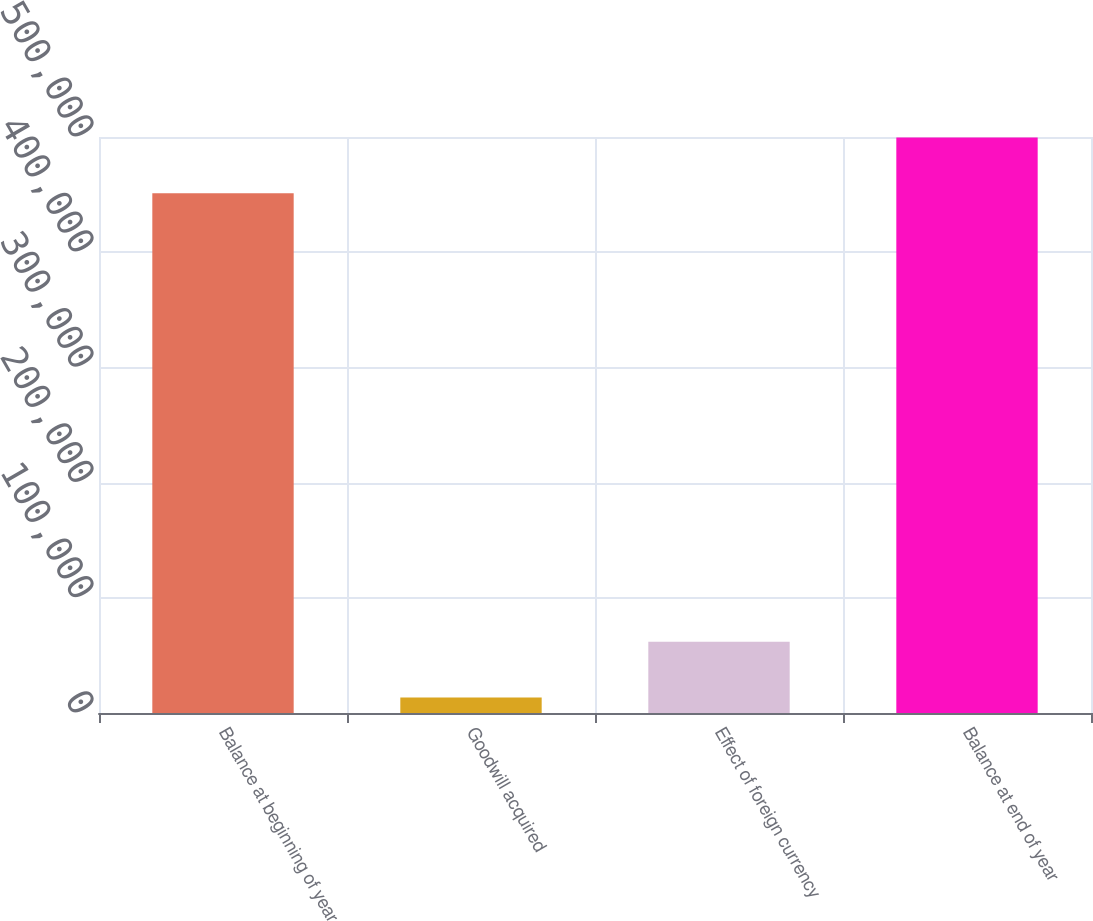<chart> <loc_0><loc_0><loc_500><loc_500><bar_chart><fcel>Balance at beginning of year<fcel>Goodwill acquired<fcel>Effect of foreign currency<fcel>Balance at end of year<nl><fcel>451244<fcel>13536<fcel>61896<fcel>499604<nl></chart> 